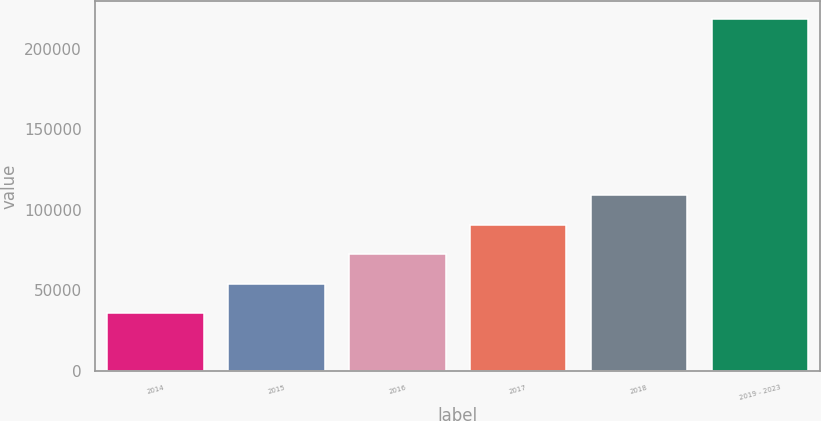<chart> <loc_0><loc_0><loc_500><loc_500><bar_chart><fcel>2014<fcel>2015<fcel>2016<fcel>2017<fcel>2018<fcel>2019 - 2023<nl><fcel>35913<fcel>54182.9<fcel>72452.8<fcel>90722.7<fcel>108993<fcel>218612<nl></chart> 